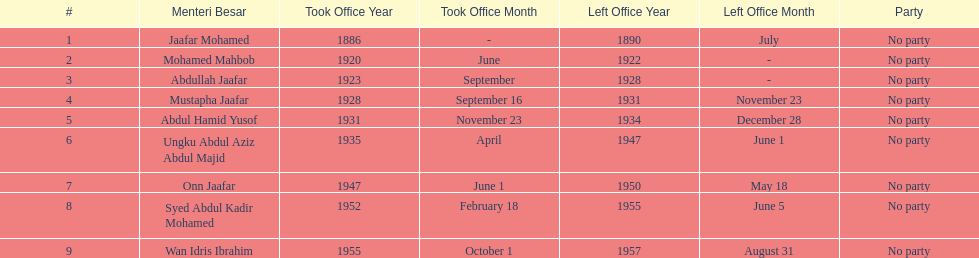How long did ungku abdul aziz abdul majid serve? 12 years. Can you parse all the data within this table? {'header': ['#', 'Menteri Besar', 'Took Office Year', 'Took Office Month', 'Left Office Year', 'Left Office Month', 'Party'], 'rows': [['1', 'Jaafar Mohamed', '1886', '-', '1890', 'July', 'No party'], ['2', 'Mohamed Mahbob', '1920', 'June', '1922', '-', 'No party'], ['3', 'Abdullah Jaafar', '1923', 'September', '1928', '-', 'No party'], ['4', 'Mustapha Jaafar', '1928', 'September 16', '1931', 'November 23', 'No party'], ['5', 'Abdul Hamid Yusof', '1931', 'November 23', '1934', 'December 28', 'No party'], ['6', 'Ungku Abdul Aziz Abdul Majid', '1935', 'April', '1947', 'June 1', 'No party'], ['7', 'Onn Jaafar', '1947', 'June 1', '1950', 'May 18', 'No party'], ['8', 'Syed Abdul Kadir Mohamed', '1952', 'February 18', '1955', 'June 5', 'No party'], ['9', 'Wan Idris Ibrahim', '1955', 'October 1', '1957', 'August 31', 'No party']]} 